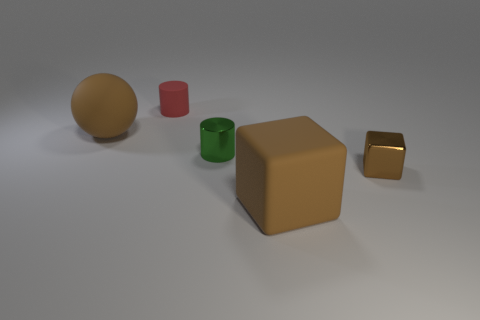Subtract all red cylinders. How many cylinders are left? 1 Subtract all cubes. How many objects are left? 3 Add 3 tiny cylinders. How many objects exist? 8 Subtract 1 blocks. How many blocks are left? 1 Subtract all small green shiny cylinders. Subtract all large brown cubes. How many objects are left? 3 Add 2 rubber things. How many rubber things are left? 5 Add 3 big green cubes. How many big green cubes exist? 3 Subtract 0 green spheres. How many objects are left? 5 Subtract all brown cylinders. Subtract all cyan balls. How many cylinders are left? 2 